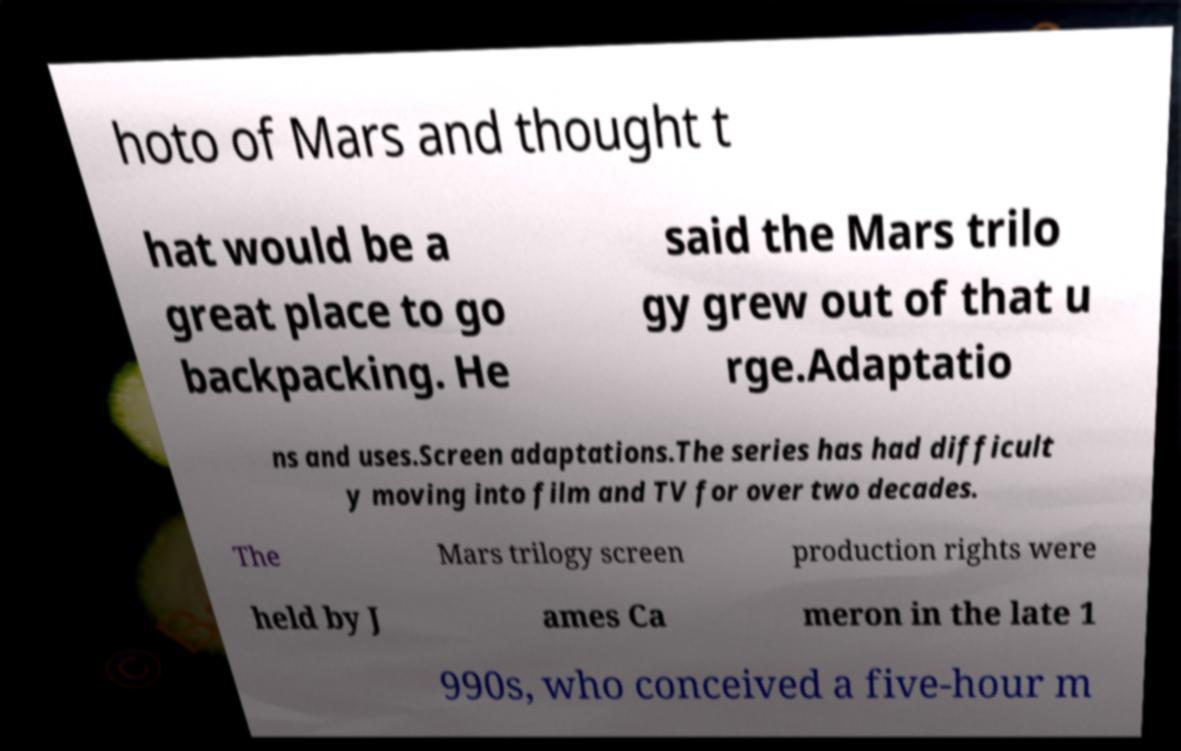There's text embedded in this image that I need extracted. Can you transcribe it verbatim? hoto of Mars and thought t hat would be a great place to go backpacking. He said the Mars trilo gy grew out of that u rge.Adaptatio ns and uses.Screen adaptations.The series has had difficult y moving into film and TV for over two decades. The Mars trilogy screen production rights were held by J ames Ca meron in the late 1 990s, who conceived a five-hour m 